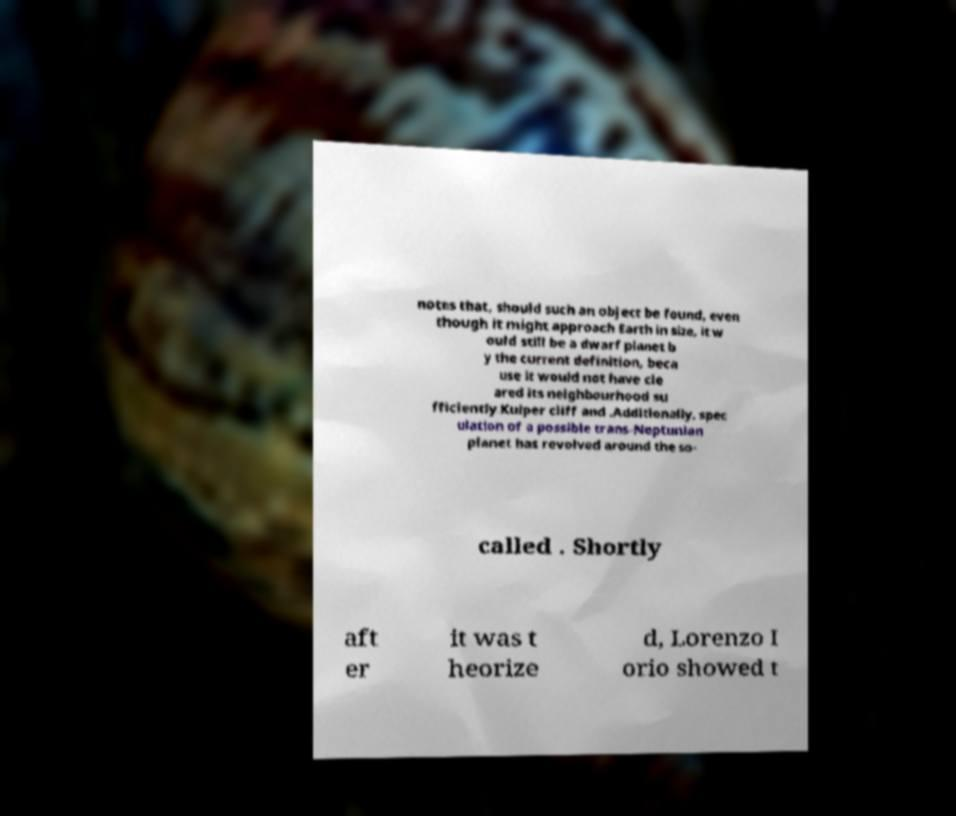There's text embedded in this image that I need extracted. Can you transcribe it verbatim? notes that, should such an object be found, even though it might approach Earth in size, it w ould still be a dwarf planet b y the current definition, beca use it would not have cle ared its neighbourhood su fficiently.Kuiper cliff and .Additionally, spec ulation of a possible trans-Neptunian planet has revolved around the so- called . Shortly aft er it was t heorize d, Lorenzo I orio showed t 